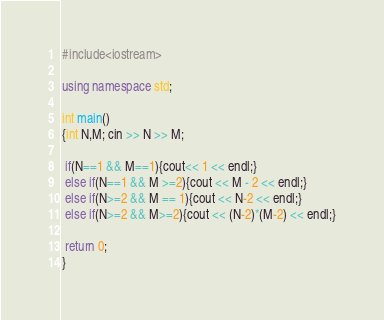<code> <loc_0><loc_0><loc_500><loc_500><_C++_>#include<iostream>

using namespace std;

int main()
{int N,M; cin >> N >> M;

 if(N==1 && M==1){cout<< 1 << endl;}
 else if(N==1 && M >=2){cout << M - 2 << endl;}
 else if(N>=2 && M == 1){cout << N-2 << endl;}
 else if(N>=2 && M>=2){cout << (N-2)*(M-2) << endl;}
 
 return 0;
}</code> 